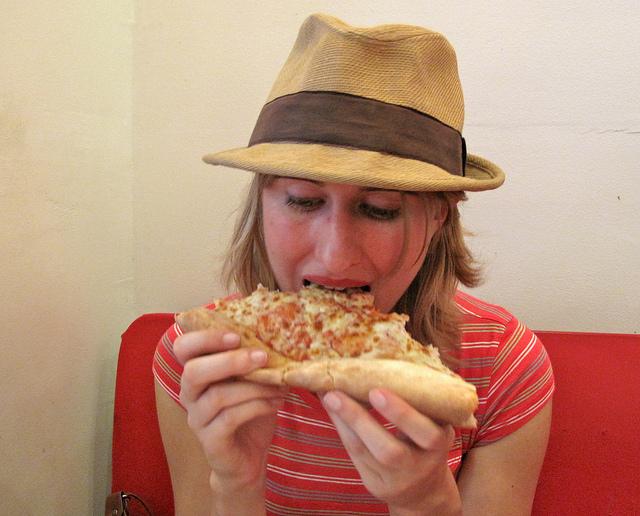Is this person eating alone?
Answer briefly. Yes. Is she going to need a napkin?
Keep it brief. Yes. What color is the ribbon?
Keep it brief. Brown. What is this person eating?
Write a very short answer. Pizza. Is the woman wearing a straw hat?
Write a very short answer. No. 